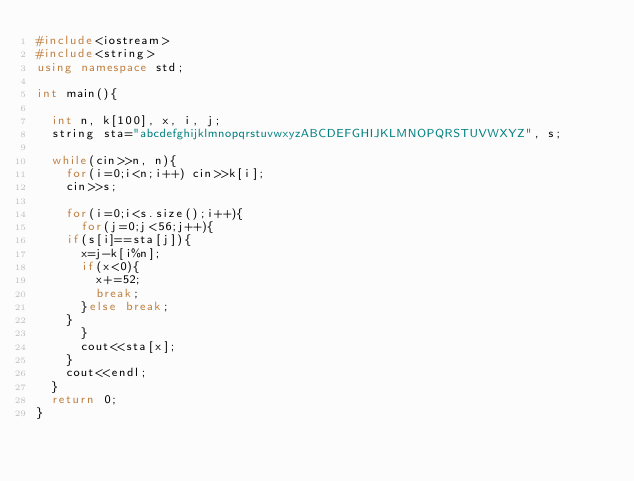Convert code to text. <code><loc_0><loc_0><loc_500><loc_500><_C++_>#include<iostream>
#include<string>
using namespace std;
 
int main(){
 
  int n, k[100], x, i, j;
  string sta="abcdefghijklmnopqrstuvwxyzABCDEFGHIJKLMNOPQRSTUVWXYZ", s;
 
  while(cin>>n, n){
    for(i=0;i<n;i++) cin>>k[i];
    cin>>s;
 
    for(i=0;i<s.size();i++){
      for(j=0;j<56;j++){
	if(s[i]==sta[j]){
	  x=j-k[i%n];
	  if(x<0){
	    x+=52;
	    break;
	  }else break;
	}
      }
      cout<<sta[x];
    }
    cout<<endl;
  }
  return 0;
}</code> 